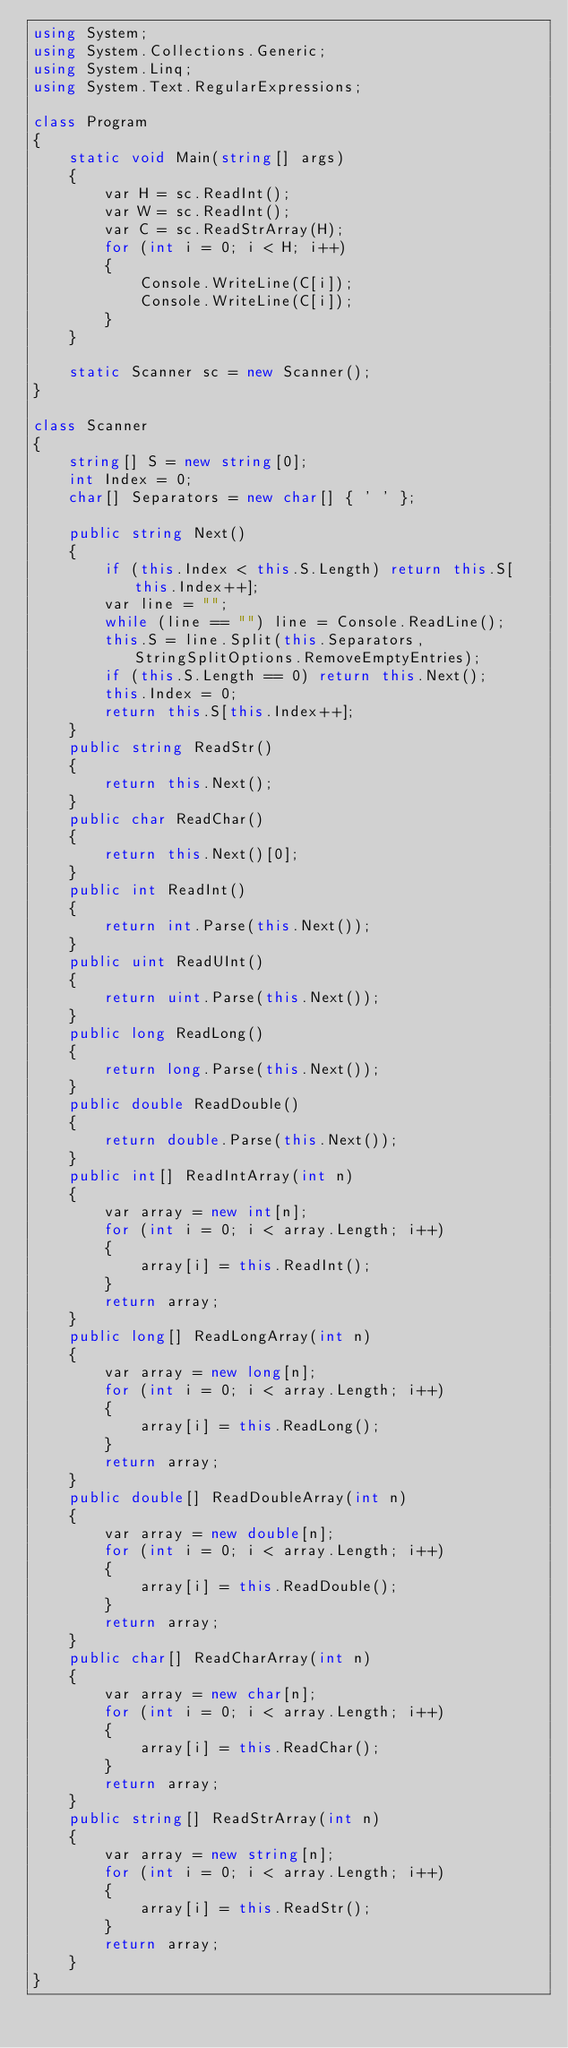<code> <loc_0><loc_0><loc_500><loc_500><_C#_>using System;
using System.Collections.Generic;
using System.Linq;
using System.Text.RegularExpressions;

class Program
{
    static void Main(string[] args)
    {
        var H = sc.ReadInt();
        var W = sc.ReadInt();
        var C = sc.ReadStrArray(H);
        for (int i = 0; i < H; i++)
        {
            Console.WriteLine(C[i]);
            Console.WriteLine(C[i]);
        }
    }

    static Scanner sc = new Scanner();
}

class Scanner
{
    string[] S = new string[0];
    int Index = 0;
    char[] Separators = new char[] { ' ' };

    public string Next()
    {
        if (this.Index < this.S.Length) return this.S[this.Index++];
        var line = "";
        while (line == "") line = Console.ReadLine();
        this.S = line.Split(this.Separators, StringSplitOptions.RemoveEmptyEntries);
        if (this.S.Length == 0) return this.Next();
        this.Index = 0;
        return this.S[this.Index++];
    }
    public string ReadStr()
    {
        return this.Next();
    }
    public char ReadChar()
    {
        return this.Next()[0];
    }
    public int ReadInt()
    {
        return int.Parse(this.Next());
    }
    public uint ReadUInt()
    {
        return uint.Parse(this.Next());
    }
    public long ReadLong()
    {
        return long.Parse(this.Next());
    }
    public double ReadDouble()
    {
        return double.Parse(this.Next());
    }
    public int[] ReadIntArray(int n)
    {
        var array = new int[n];
        for (int i = 0; i < array.Length; i++)
        {
            array[i] = this.ReadInt();
        }
        return array;
    }
    public long[] ReadLongArray(int n)
    {
        var array = new long[n];
        for (int i = 0; i < array.Length; i++)
        {
            array[i] = this.ReadLong();
        }
        return array;
    }
    public double[] ReadDoubleArray(int n)
    {
        var array = new double[n];
        for (int i = 0; i < array.Length; i++)
        {
            array[i] = this.ReadDouble();
        }
        return array;
    }
    public char[] ReadCharArray(int n)
    {
        var array = new char[n];
        for (int i = 0; i < array.Length; i++)
        {
            array[i] = this.ReadChar();
        }
        return array;
    }
    public string[] ReadStrArray(int n)
    {
        var array = new string[n];
        for (int i = 0; i < array.Length; i++)
        {
            array[i] = this.ReadStr();
        }
        return array;
    }
}
</code> 